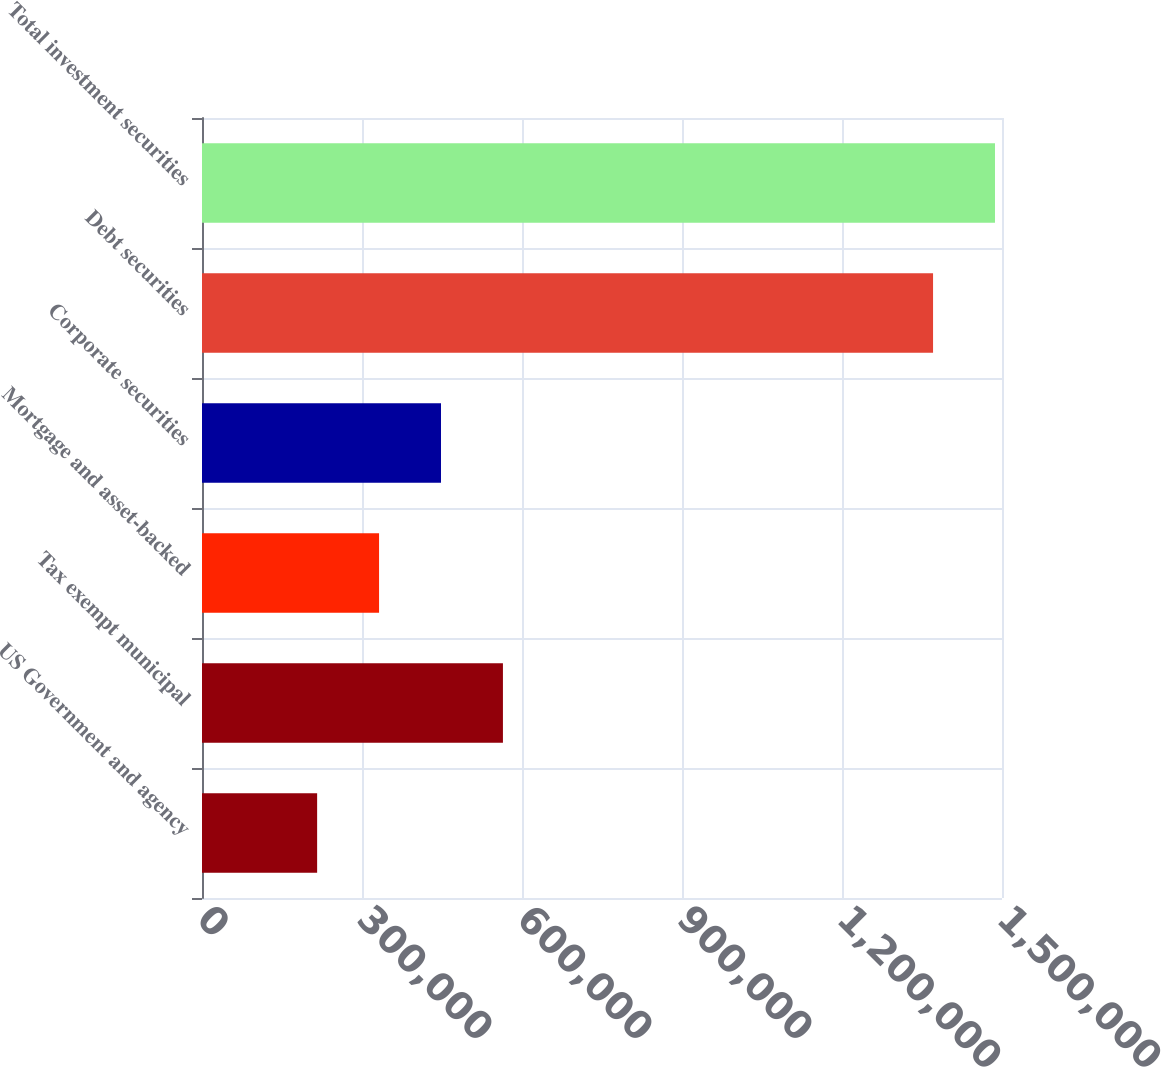<chart> <loc_0><loc_0><loc_500><loc_500><bar_chart><fcel>US Government and agency<fcel>Tax exempt municipal<fcel>Mortgage and asset-backed<fcel>Corporate securities<fcel>Debt securities<fcel>Total investment securities<nl><fcel>215871<fcel>564248<fcel>331997<fcel>448122<fcel>1.37072e+06<fcel>1.48685e+06<nl></chart> 